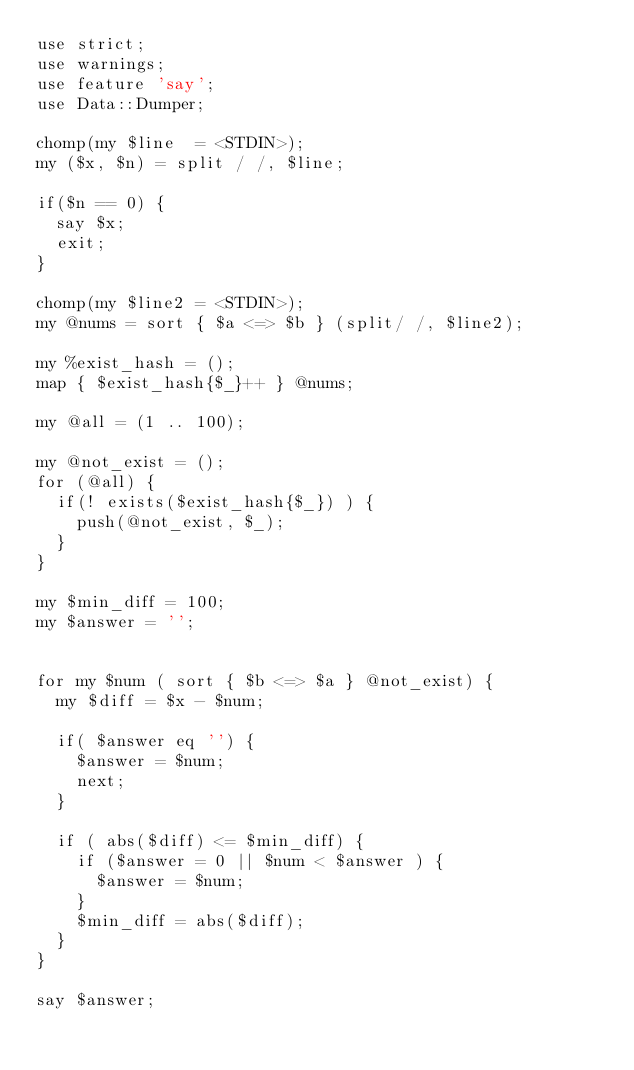Convert code to text. <code><loc_0><loc_0><loc_500><loc_500><_Perl_>use strict;
use warnings;
use feature 'say';
use Data::Dumper;

chomp(my $line  = <STDIN>);
my ($x, $n) = split / /, $line;

if($n == 0) {
  say $x;
  exit;
}

chomp(my $line2 = <STDIN>);
my @nums = sort { $a <=> $b } (split/ /, $line2);

my %exist_hash = ();
map { $exist_hash{$_}++ } @nums;

my @all = (1 .. 100);

my @not_exist = ();
for (@all) {
  if(! exists($exist_hash{$_}) ) {
    push(@not_exist, $_);
  }
}

my $min_diff = 100;
my $answer = '';


for my $num ( sort { $b <=> $a } @not_exist) {
  my $diff = $x - $num;

  if( $answer eq '') {
    $answer = $num;
    next;
  }

  if ( abs($diff) <= $min_diff) {
    if ($answer = 0 || $num < $answer ) {
      $answer = $num;
    }
    $min_diff = abs($diff);
  }
}

say $answer;


</code> 